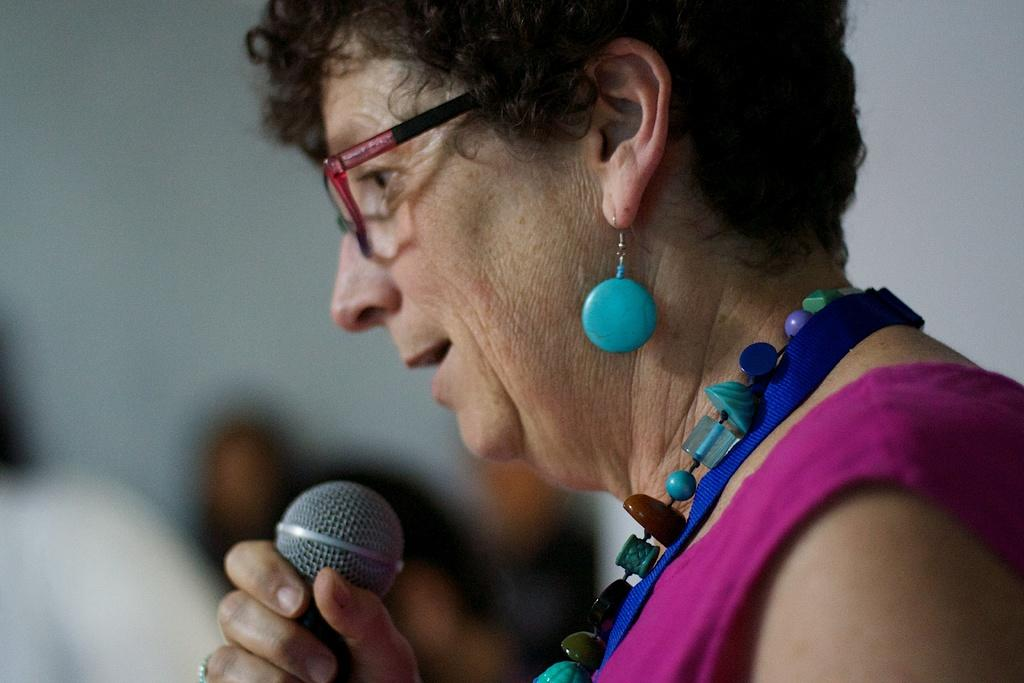What is the main subject of the image? There is a person in the image. What is the person doing in the image? The person is standing in the image. What object is the person holding in the image? The person is holding a microphone in the image. What is the person wearing in the image? The person is wearing a pink dress and colorful jewelry in the image. What type of silk fabric is used to make the person's dress in the image? The person's dress is made of a pink dress, not silk, as mentioned in the facts. 